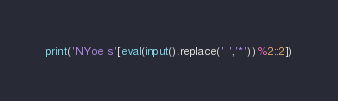Convert code to text. <code><loc_0><loc_0><loc_500><loc_500><_Python_>print('NYoe s'[eval(input().replace(' ','*'))%2::2])</code> 